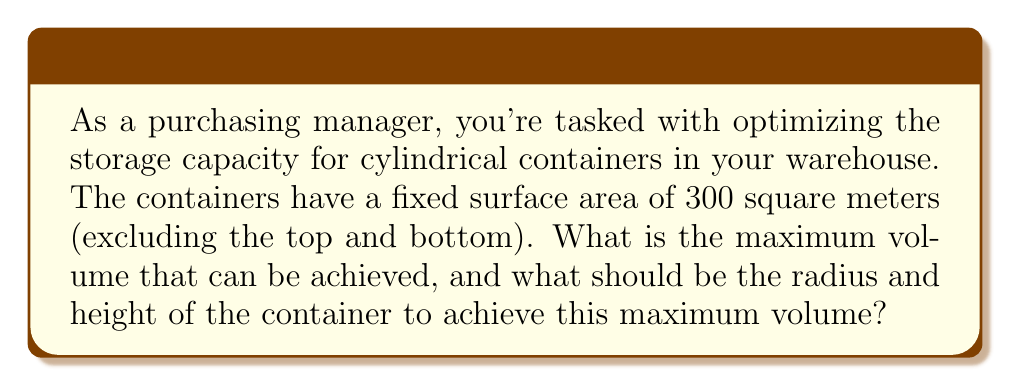Could you help me with this problem? Let's approach this step-by-step:

1) For a cylinder, let $r$ be the radius and $h$ be the height.

2) The surface area of the lateral side (excluding top and bottom) is given by:
   $$ A = 2\pi rh $$

3) We're told that this area is fixed at 300 m², so:
   $$ 2\pi rh = 300 $$

4) The volume of a cylinder is given by:
   $$ V = \pi r^2h $$

5) We want to maximize this volume. From step 3, we can express $h$ in terms of $r$:
   $$ h = \frac{300}{2\pi r} $$

6) Substituting this into the volume formula:
   $$ V = \pi r^2 \cdot \frac{300}{2\pi r} = 150r $$

7) To find the maximum, we differentiate V with respect to r:
   $$ \frac{dV}{dr} = 150 $$

8) This is always positive, indicating that V increases as r increases. However, we have a constraint: as r increases, h must decrease to maintain the fixed surface area.

9) The optimal ratio for a cylinder with fixed surface area is when $h = 2r$. Applying this to our surface area equation:
   $$ 2\pi r(2r) = 300 $$
   $$ 4\pi r^2 = 300 $$
   $$ r^2 = \frac{75}{\pi} $$
   $$ r = \sqrt{\frac{75}{\pi}} \approx 4.8860 \text{ m} $$

10) The corresponding height is:
    $$ h = 2r = 2\sqrt{\frac{75}{\pi}} \approx 9.7720 \text{ m} $$

11) The maximum volume is thus:
    $$ V = \pi r^2h = \pi \cdot (\frac{75}{\pi}) \cdot (2\sqrt{\frac{75}{\pi}}) = 150\sqrt{\frac{75}{\pi}} \approx 732.8984 \text{ m}^3 $$
Answer: The maximum volume is approximately 732.8984 m³, achieved with a radius of 4.8860 m and a height of 9.7720 m. 